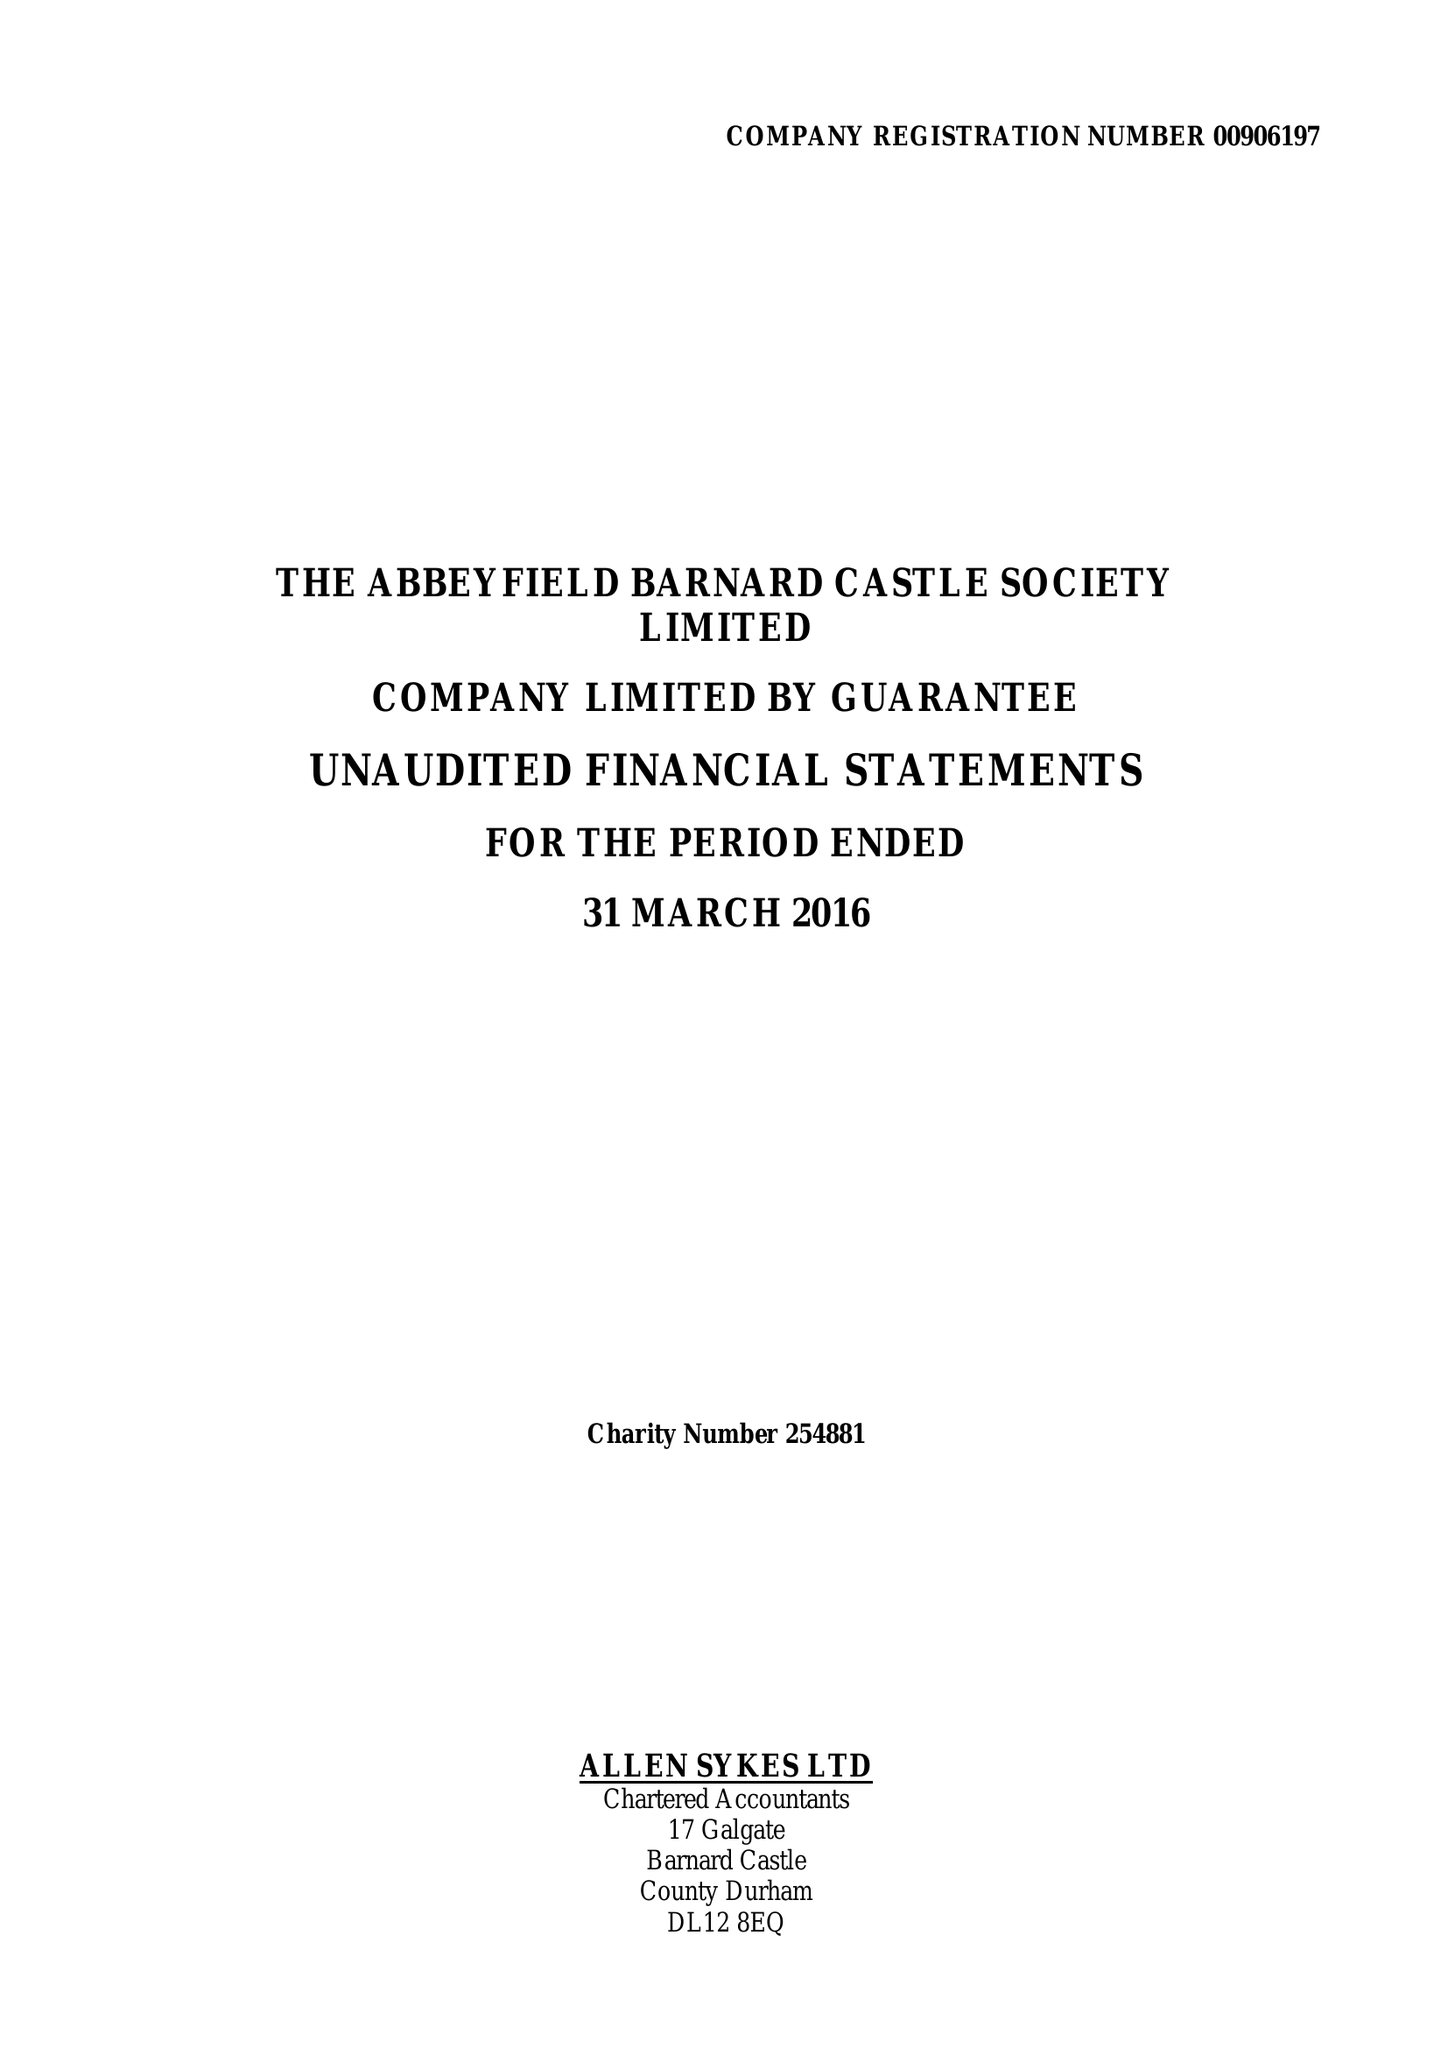What is the value for the charity_name?
Answer the question using a single word or phrase. The Abbeyfield Barnard Castle Society Ltd. 